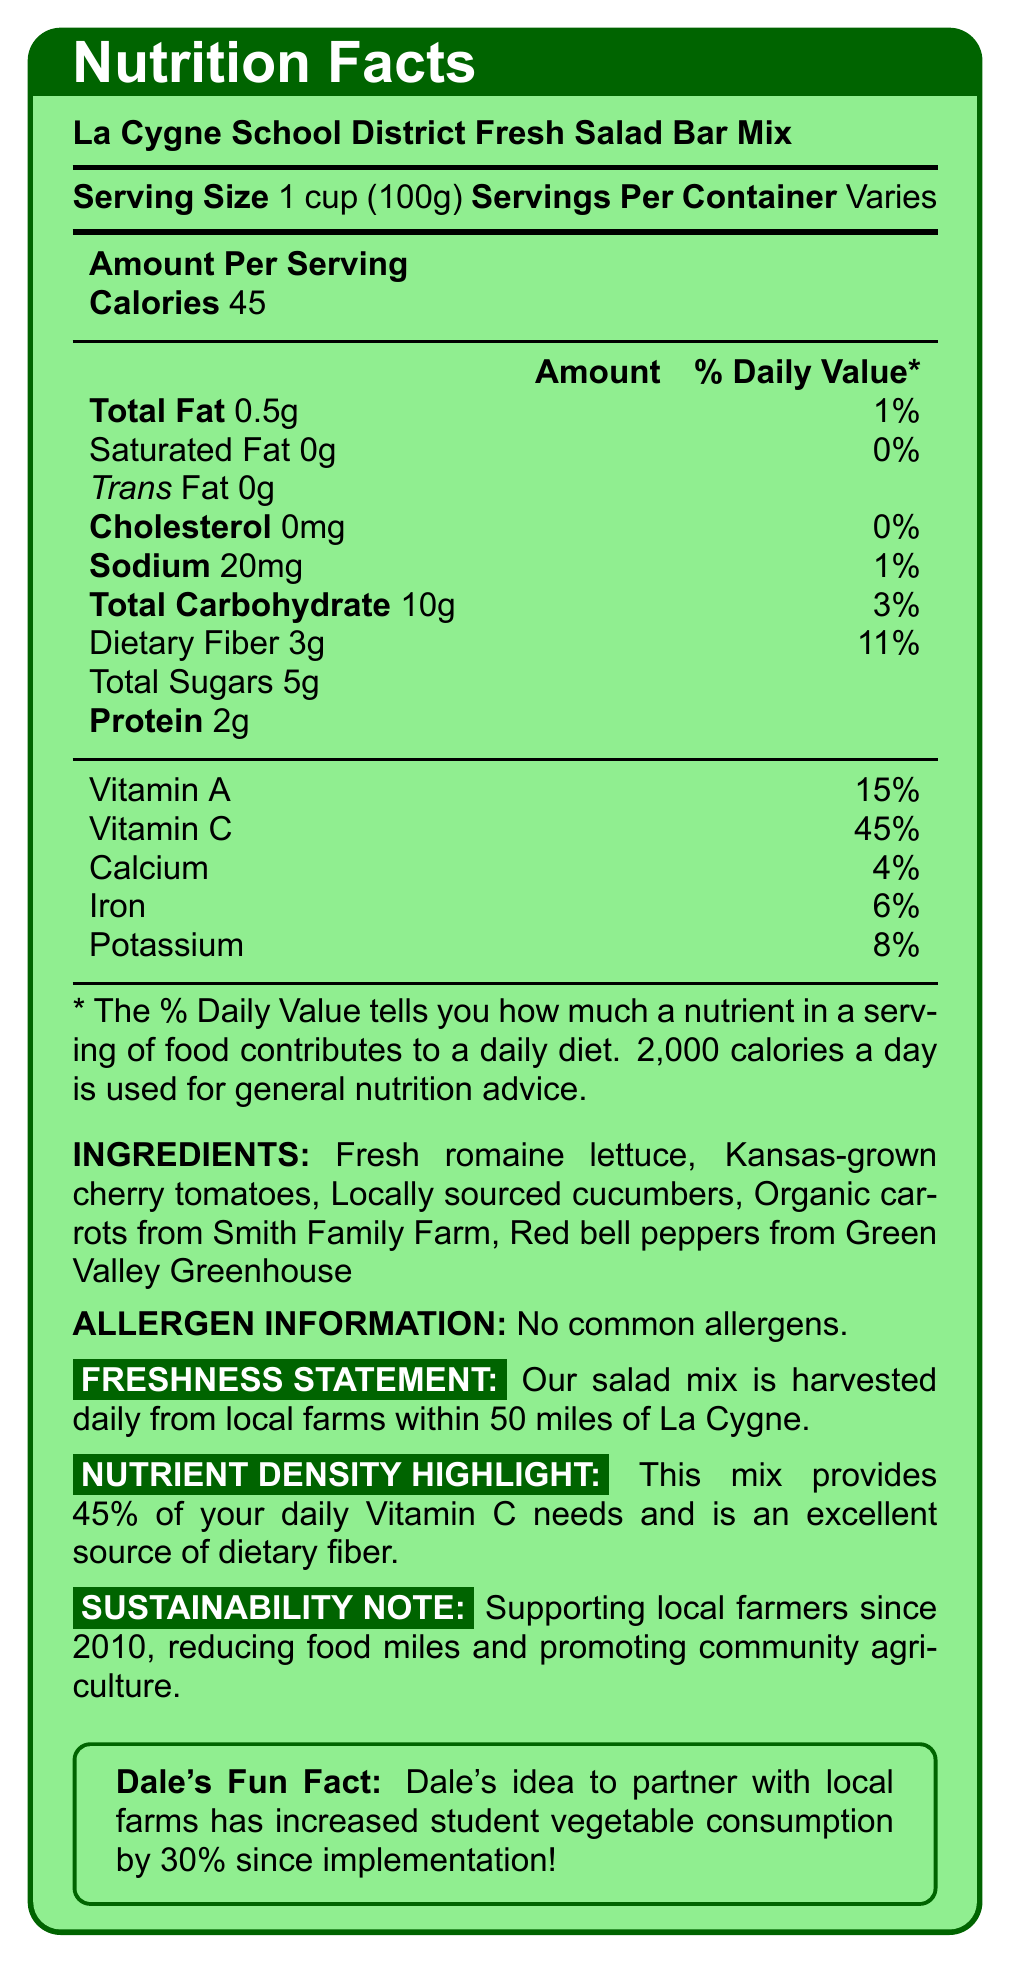what is the serving size for the Fresh Salad Bar Mix? The serving size is clearly mentioned in the document as 1 cup, which is equivalent to 100g.
Answer: 1 cup (100g) how many calories are in one serving of the salad mix? The document states that there are 45 calories per serving.
Answer: 45 calories how much dietary fiber does one serving contain? The amount of dietary fiber per serving is listed as 3g.
Answer: 3g what percentage of daily Vitamin C needs does this salad mix provide? The document states that the salad mix provides 45% of the daily Vitamin C needs.
Answer: 45% what are the ingredients in the salad mix? The ingredients section of the document lists all these items.
Answer: Fresh romaine lettuce, Kansas-grown cherry tomatoes, Locally sourced cucumbers, Organic carrots from Smith Family Farm, Red bell peppers from Green Valley Greenhouse which nutrient is abundant in this salad mix, according to the nutrient density highlight? A. Protein B. Vitamin C C. Calcium D. Sodium The nutrient density highlight mentions that the mix provides 45% of the daily Vitamin C needs.
Answer: B. Vitamin C how is the salad mix harvested? A. Weekly B. Bi-weekly C. Daily D. Monthly The freshness statement indicates that the salad mix is harvested daily from local farms.
Answer: C. Daily does the salad mix contain any common allergens? The allergen information clearly states that there are no common allergens.
Answer: No is the salad mix beneficial for fiber intake? The nutrient density highlight mentions that it is an excellent source of dietary fiber.
Answer: Yes how far are the farms from which the salad mix is sourced? The freshness statement notes that the mix is harvested from local farms within 50 miles of La Cygne.
Answer: Within 50 miles of La Cygne describe the main idea of the document. The document provides comprehensive information about the salad mix, including its nutritional values, ingredient sources, freshness statement, and efforts towards sustainability.
Answer: The document explains the nutritional information, ingredients, allergen information, and sourcing details about the La Cygne School District Fresh Salad Bar Mix, emphasizing its freshness, high nutrient content, and local sourcing. when was the initiative to support local farmers started? The document mentions that local farmers have been supported since 2010, but it doesn’t provide the exact start date of the specific initiative to support them.
Answer: Not enough information identify an initiative Dale implemented. The fun fact section highlights that Dale’s idea to partner with local farms increased student vegetable consumption by 30%.
Answer: Partnering with local farms to increase student vegetable consumption how much sodium does one serving of the salad mix contain? The amount of sodium per serving is listed as 20mg in the document.
Answer: 20mg 